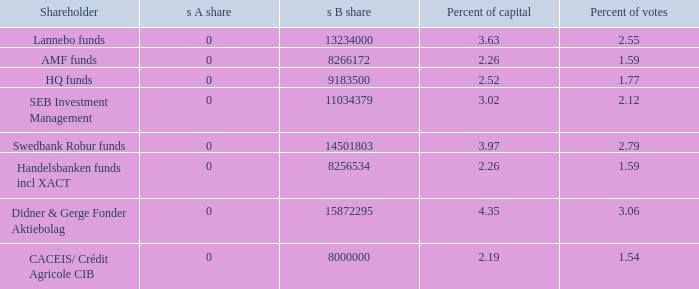What is the s B share for Handelsbanken funds incl XACT? 8256534.0. 